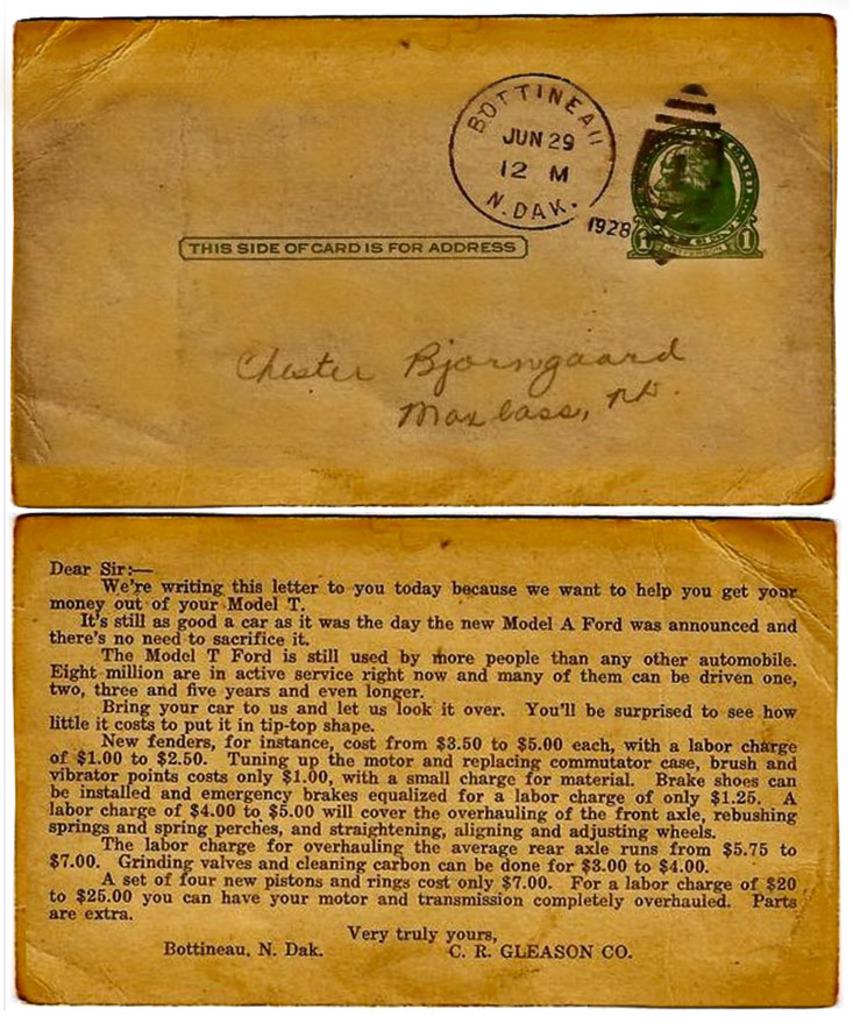What date was this mailed?
Keep it short and to the point. June 29. Who was this sent to?
Offer a very short reply. Chester bjorngaard. 